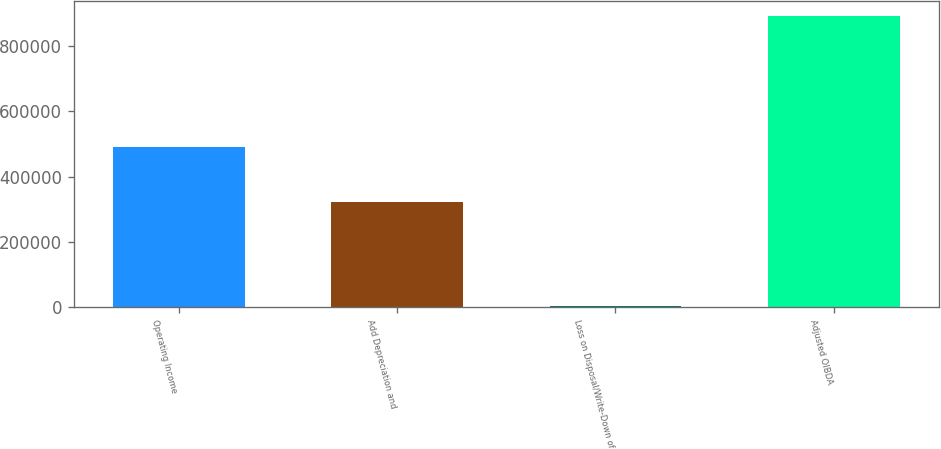Convert chart to OTSL. <chart><loc_0><loc_0><loc_500><loc_500><bar_chart><fcel>Operating Income<fcel>Add Depreciation and<fcel>Loss on Disposal/Write-Down of<fcel>Adjusted OIBDA<nl><fcel>489247<fcel>322037<fcel>430<fcel>894581<nl></chart> 